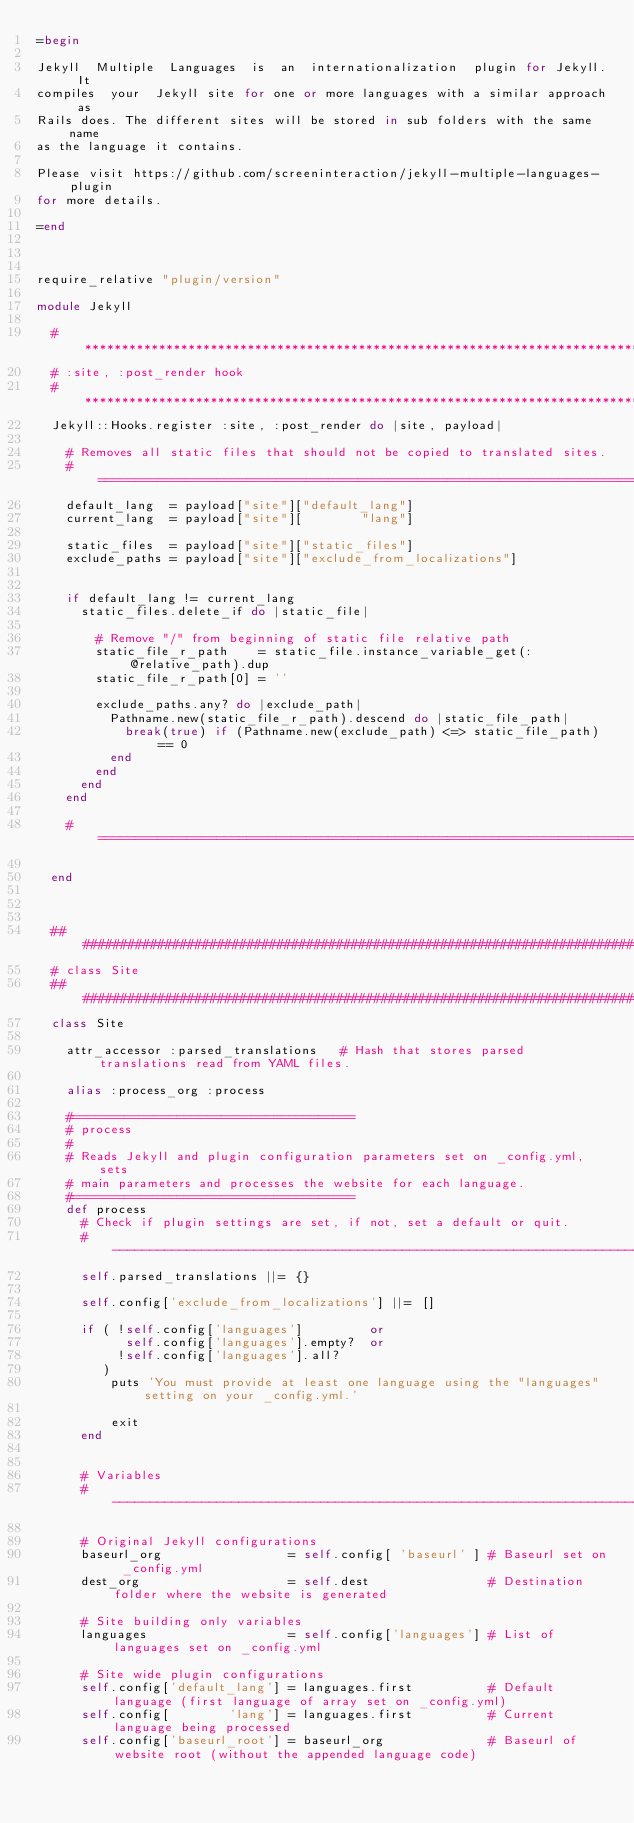Convert code to text. <code><loc_0><loc_0><loc_500><loc_500><_Ruby_>=begin

Jekyll  Multiple  Languages  is  an  internationalization  plugin for Jekyll. It
compiles  your  Jekyll site for one or more languages with a similar approach as
Rails does. The different sites will be stored in sub folders with the same name
as the language it contains.

Please visit https://github.com/screeninteraction/jekyll-multiple-languages-plugin
for more details.

=end



require_relative "plugin/version"

module Jekyll

  #*****************************************************************************
  # :site, :post_render hook
  #*****************************************************************************
  Jekyll::Hooks.register :site, :post_render do |site, payload|
    
    # Removes all static files that should not be copied to translated sites.
    #===========================================================================
    default_lang  = payload["site"]["default_lang"]
    current_lang  = payload["site"][        "lang"]
    
    static_files  = payload["site"]["static_files"]
    exclude_paths = payload["site"]["exclude_from_localizations"]
    
    
    if default_lang != current_lang
      static_files.delete_if do |static_file|
          
        # Remove "/" from beginning of static file relative path
        static_file_r_path    = static_file.instance_variable_get(:@relative_path).dup
        static_file_r_path[0] = ''
        
        exclude_paths.any? do |exclude_path|
          Pathname.new(static_file_r_path).descend do |static_file_path|
            break(true) if (Pathname.new(exclude_path) <=> static_file_path) == 0
          end
        end
      end
    end
    
    #===========================================================================
    
  end



  ##############################################################################
  # class Site
  ##############################################################################
  class Site
    
    attr_accessor :parsed_translations   # Hash that stores parsed translations read from YAML files.
    
    alias :process_org :process
    
    #======================================
    # process
    #
    # Reads Jekyll and plugin configuration parameters set on _config.yml, sets
    # main parameters and processes the website for each language.
    #======================================
    def process
      # Check if plugin settings are set, if not, set a default or quit.
      #-------------------------------------------------------------------------
      self.parsed_translations ||= {}
      
      self.config['exclude_from_localizations'] ||= []
      
      if ( !self.config['languages']         or
            self.config['languages'].empty?  or
           !self.config['languages'].all?
         )
          puts 'You must provide at least one language using the "languages" setting on your _config.yml.'
          
          exit
      end
      
      
      # Variables
      #-------------------------------------------------------------------------
      
      # Original Jekyll configurations
      baseurl_org                 = self.config[ 'baseurl' ] # Baseurl set on _config.yml
      dest_org                    = self.dest                # Destination folder where the website is generated
      
      # Site building only variables
      languages                   = self.config['languages'] # List of languages set on _config.yml
      
      # Site wide plugin configurations
      self.config['default_lang'] = languages.first          # Default language (first language of array set on _config.yml)
      self.config[        'lang'] = languages.first          # Current language being processed
      self.config['baseurl_root'] = baseurl_org              # Baseurl of website root (without the appended language code)</code> 